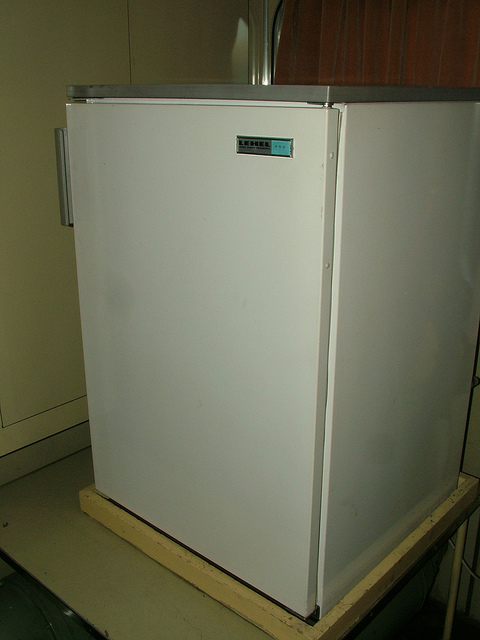<image>Whose house is this? It is unknown whose house this is. Whose house is this? It is unclear whose house this is. It could belong to the speaker, their neighbor, a bachelor, a college student, a man, Tim, the speaker's dad, or the owner. 